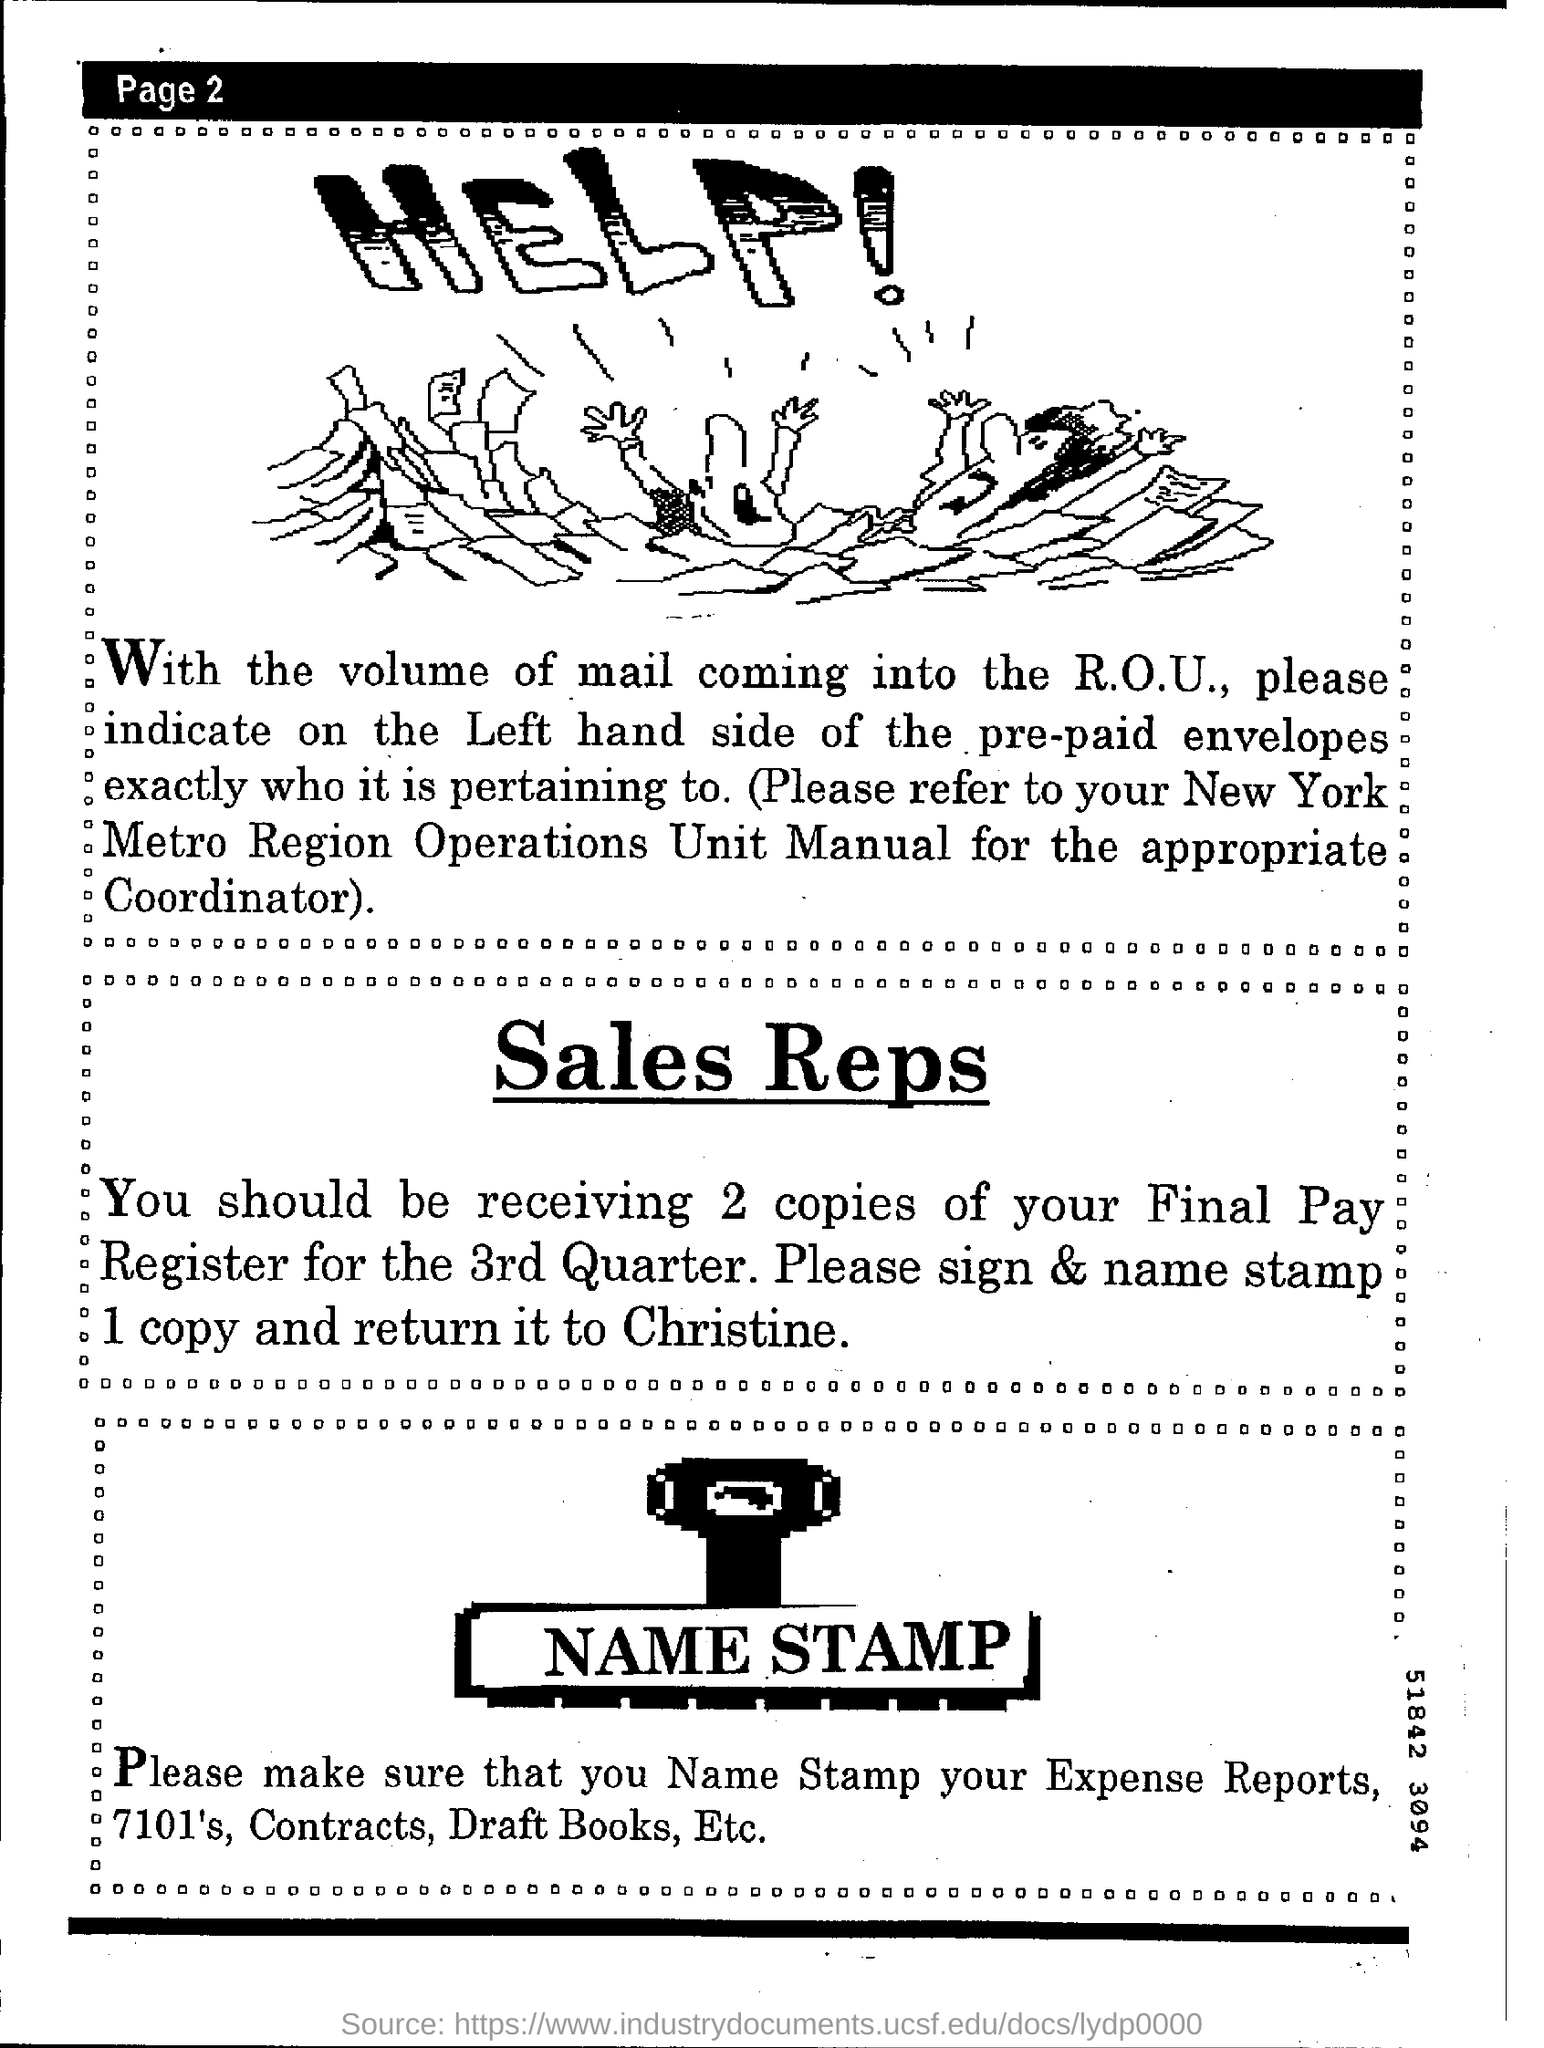List a handful of essential elements in this visual. You should refer to the appropriate coordinator for the New York Metro Region Operations Unit Manual. It is advisable to name stamps for use in expense reports, 7101's, contracts, and draft books. You should sign and name stamp one copy of the final pay register for the 3rd quarter for Christine. 